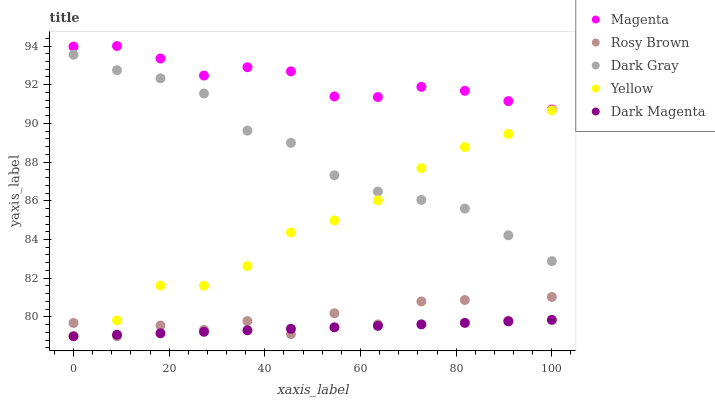Does Dark Magenta have the minimum area under the curve?
Answer yes or no. Yes. Does Magenta have the maximum area under the curve?
Answer yes or no. Yes. Does Rosy Brown have the minimum area under the curve?
Answer yes or no. No. Does Rosy Brown have the maximum area under the curve?
Answer yes or no. No. Is Dark Magenta the smoothest?
Answer yes or no. Yes. Is Rosy Brown the roughest?
Answer yes or no. Yes. Is Magenta the smoothest?
Answer yes or no. No. Is Magenta the roughest?
Answer yes or no. No. Does Rosy Brown have the lowest value?
Answer yes or no. Yes. Does Magenta have the lowest value?
Answer yes or no. No. Does Magenta have the highest value?
Answer yes or no. Yes. Does Rosy Brown have the highest value?
Answer yes or no. No. Is Rosy Brown less than Dark Gray?
Answer yes or no. Yes. Is Magenta greater than Yellow?
Answer yes or no. Yes. Does Yellow intersect Dark Magenta?
Answer yes or no. Yes. Is Yellow less than Dark Magenta?
Answer yes or no. No. Is Yellow greater than Dark Magenta?
Answer yes or no. No. Does Rosy Brown intersect Dark Gray?
Answer yes or no. No. 